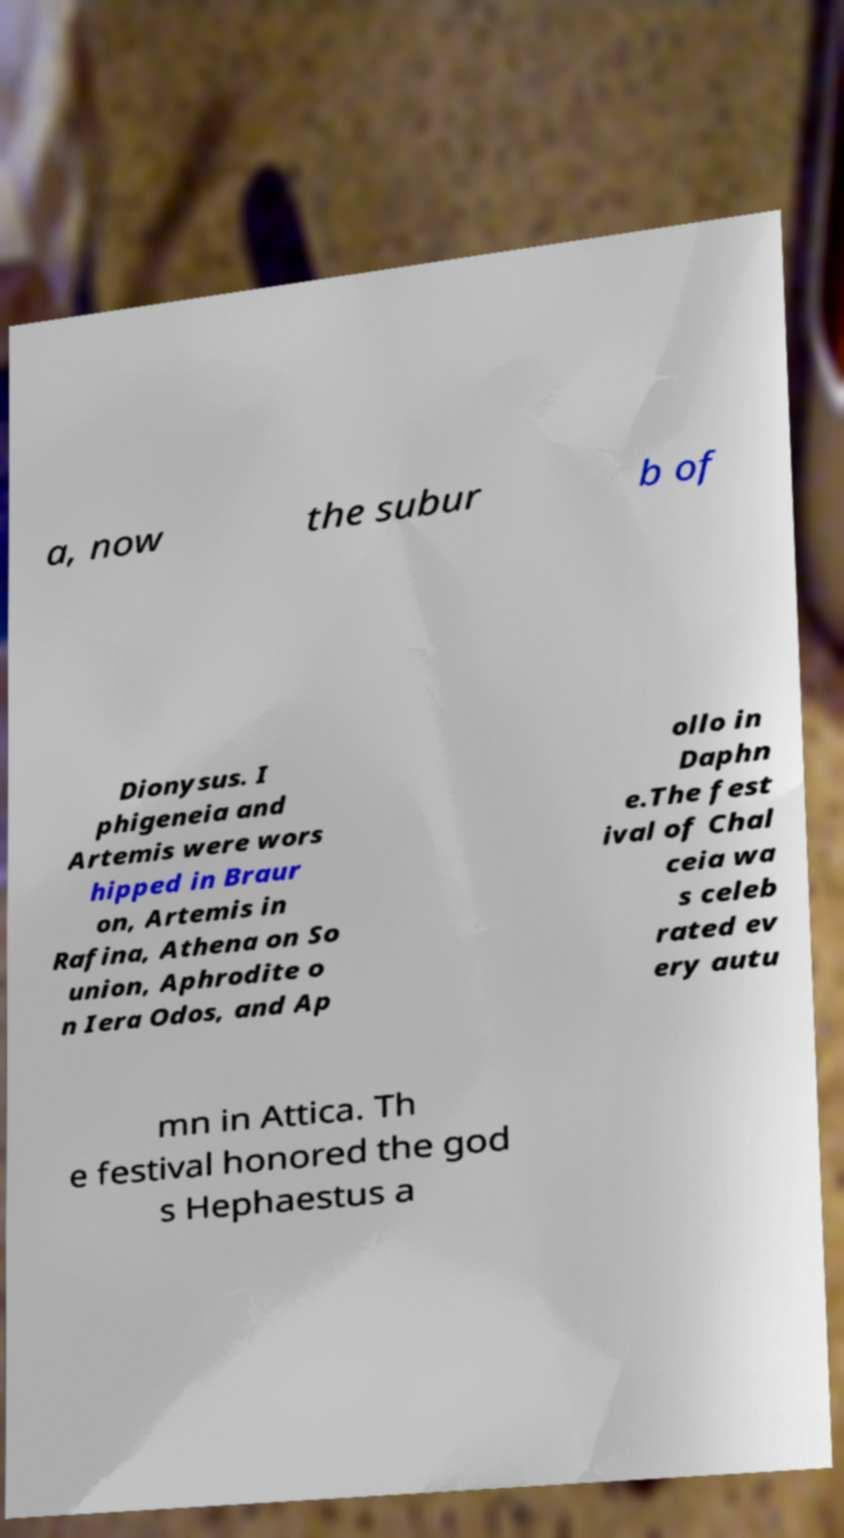Could you assist in decoding the text presented in this image and type it out clearly? a, now the subur b of Dionysus. I phigeneia and Artemis were wors hipped in Braur on, Artemis in Rafina, Athena on So union, Aphrodite o n Iera Odos, and Ap ollo in Daphn e.The fest ival of Chal ceia wa s celeb rated ev ery autu mn in Attica. Th e festival honored the god s Hephaestus a 